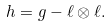Convert formula to latex. <formula><loc_0><loc_0><loc_500><loc_500>h = g - \ell \otimes \ell .</formula> 